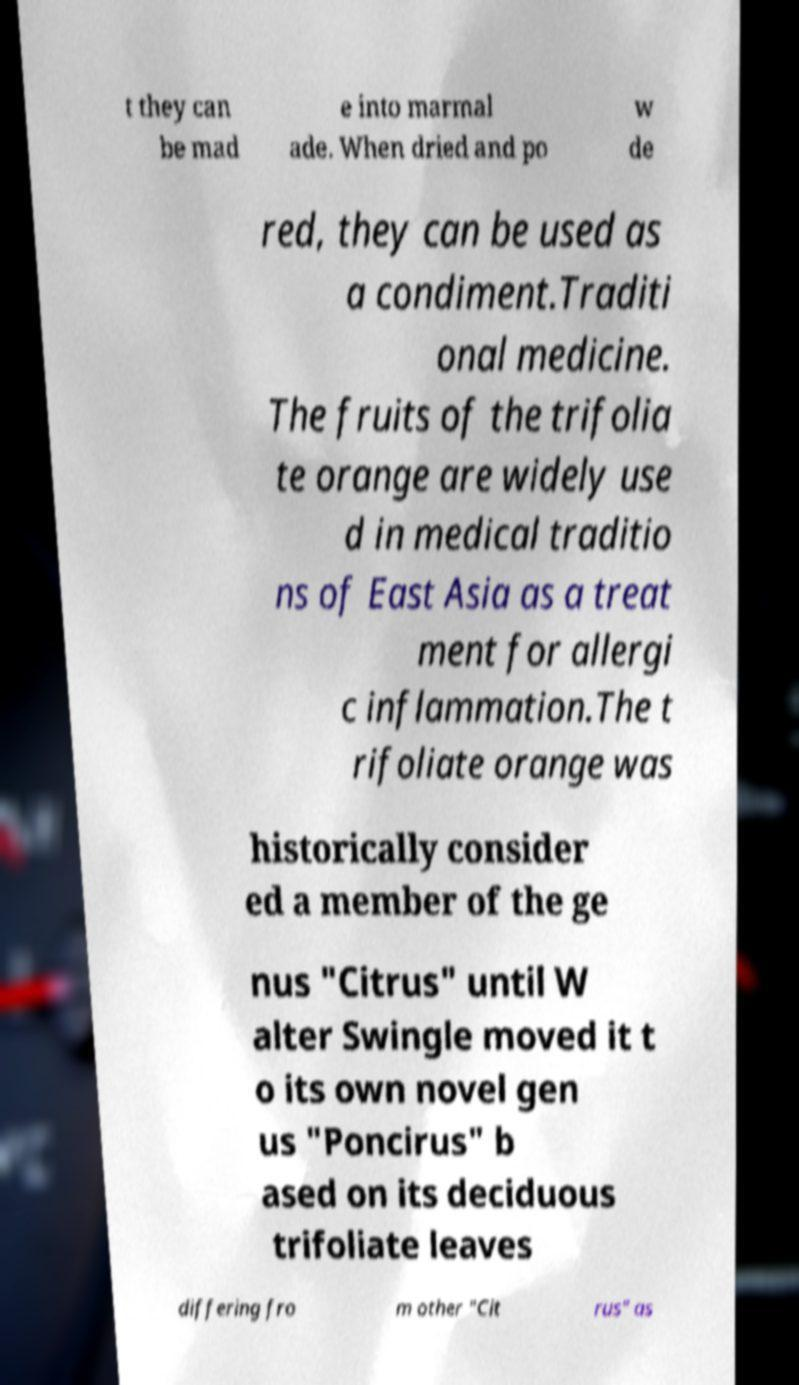For documentation purposes, I need the text within this image transcribed. Could you provide that? t they can be mad e into marmal ade. When dried and po w de red, they can be used as a condiment.Traditi onal medicine. The fruits of the trifolia te orange are widely use d in medical traditio ns of East Asia as a treat ment for allergi c inflammation.The t rifoliate orange was historically consider ed a member of the ge nus "Citrus" until W alter Swingle moved it t o its own novel gen us "Poncirus" b ased on its deciduous trifoliate leaves differing fro m other "Cit rus" as 